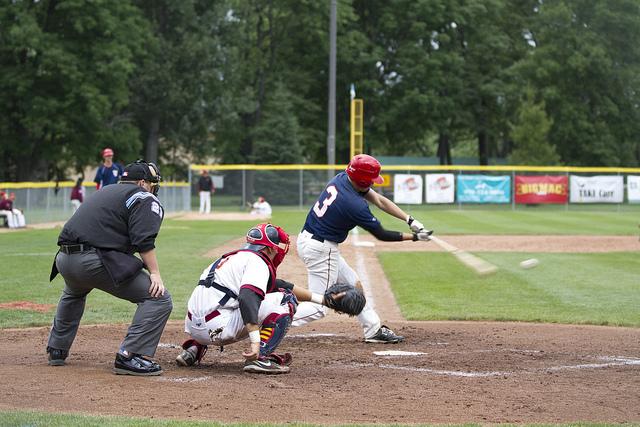How fast was the pitch?
Be succinct. Fast. Is the man in the Red Hat swinging at a ball?
Quick response, please. Yes. How many signs are in the back?
Write a very short answer. 6. What is the man in black doing?
Answer briefly. Umpiring. 